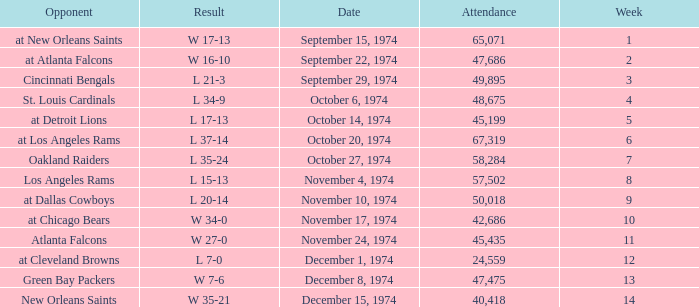What was the result before week 13 when they played the Oakland Raiders? L 35-24. 